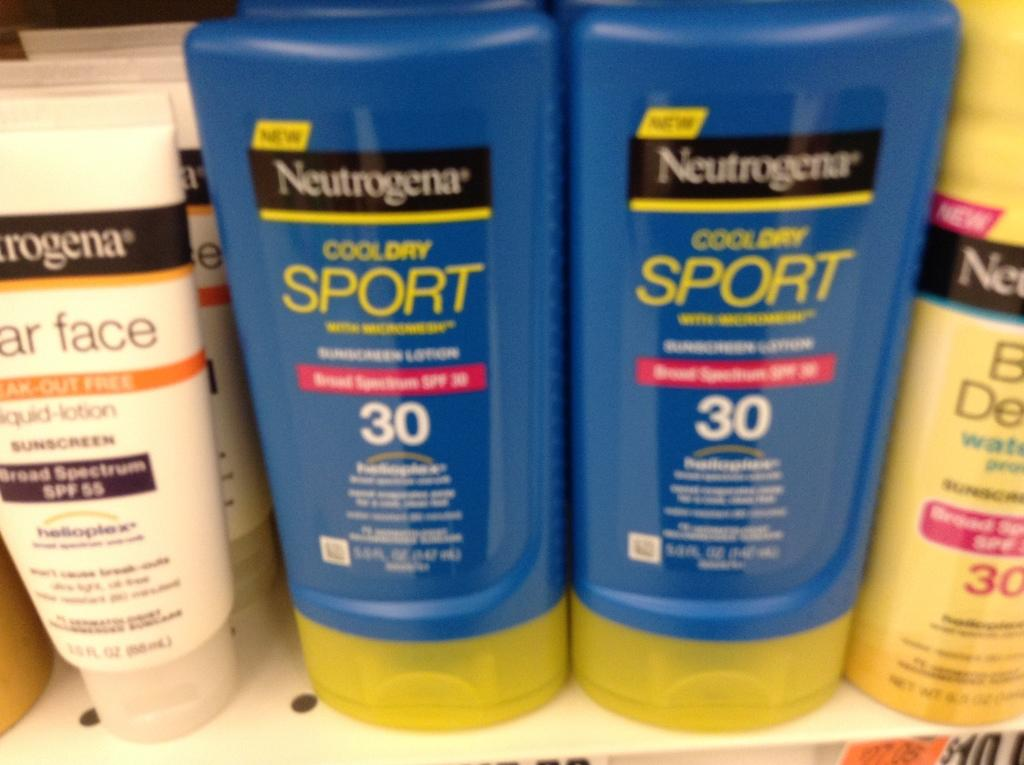<image>
Share a concise interpretation of the image provided. Blue tubes containing Neutrogena cool dry sport shampoo. 